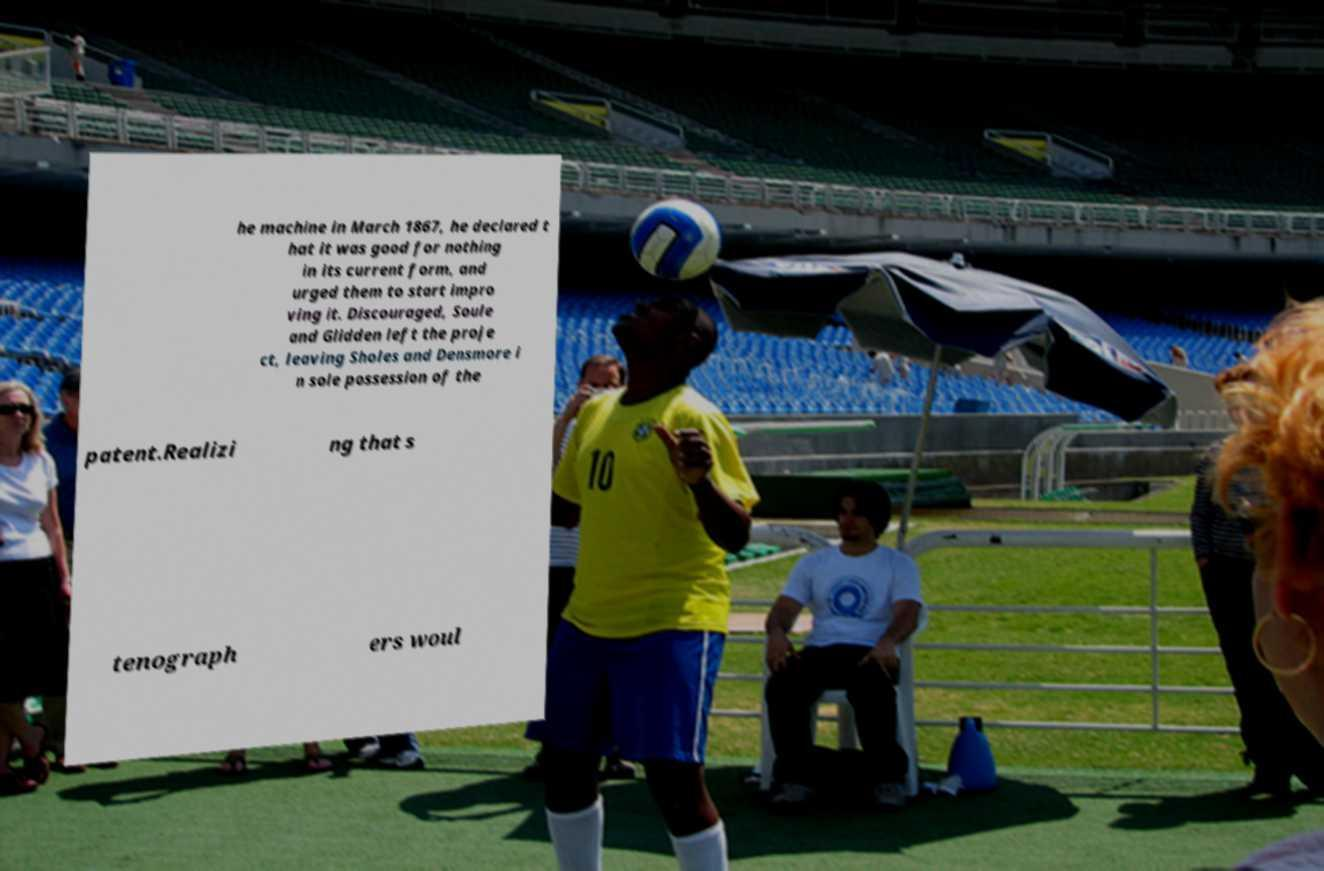Could you assist in decoding the text presented in this image and type it out clearly? he machine in March 1867, he declared t hat it was good for nothing in its current form, and urged them to start impro ving it. Discouraged, Soule and Glidden left the proje ct, leaving Sholes and Densmore i n sole possession of the patent.Realizi ng that s tenograph ers woul 